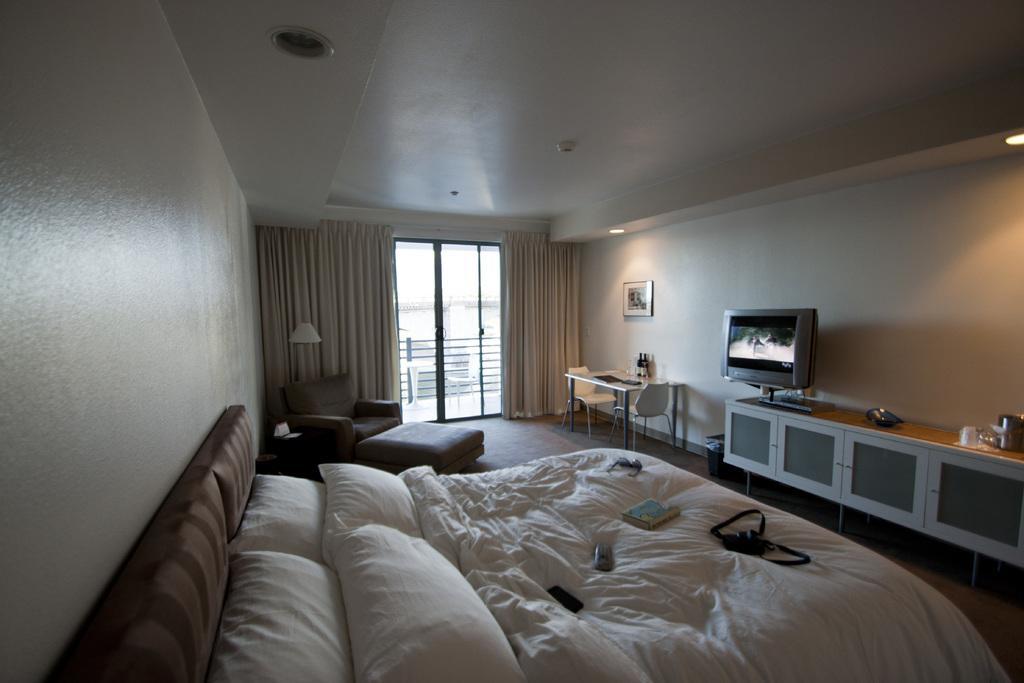Describe this image in one or two sentences. This is clicked in a bedroom, there is bed in the front followed by recliner beside it and on the right side there is tv on the table, beside it there is table and chair with a photo above it on the wall, in the back there is a glass door with curtains. 